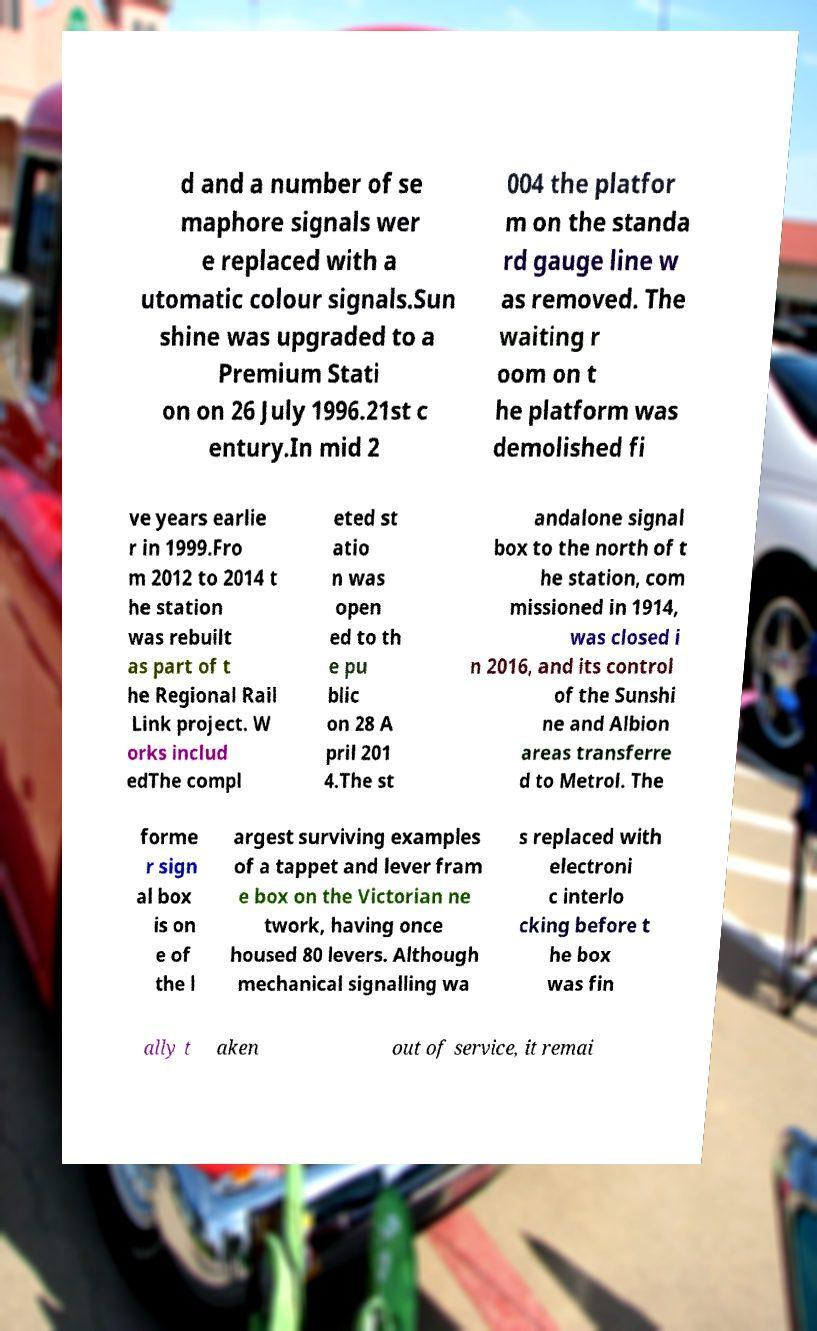Please identify and transcribe the text found in this image. d and a number of se maphore signals wer e replaced with a utomatic colour signals.Sun shine was upgraded to a Premium Stati on on 26 July 1996.21st c entury.In mid 2 004 the platfor m on the standa rd gauge line w as removed. The waiting r oom on t he platform was demolished fi ve years earlie r in 1999.Fro m 2012 to 2014 t he station was rebuilt as part of t he Regional Rail Link project. W orks includ edThe compl eted st atio n was open ed to th e pu blic on 28 A pril 201 4.The st andalone signal box to the north of t he station, com missioned in 1914, was closed i n 2016, and its control of the Sunshi ne and Albion areas transferre d to Metrol. The forme r sign al box is on e of the l argest surviving examples of a tappet and lever fram e box on the Victorian ne twork, having once housed 80 levers. Although mechanical signalling wa s replaced with electroni c interlo cking before t he box was fin ally t aken out of service, it remai 